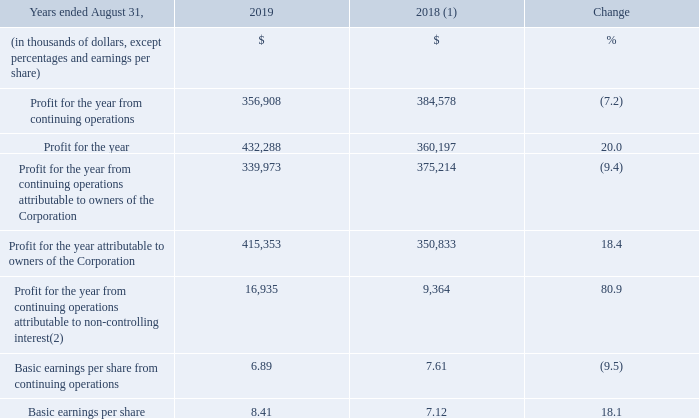3.6 PROFIT FOR THE YEAR
(1) Fiscal 2018 was restated to comply with IFRS 15 and to reflect a change in accounting policy as well as to reclassify results from Cogeco Peer 1 as discontinued operations. For further details, please consult the "Accounting policies" and "Discontinued operations" sections.
(2) The non-controlling interest represents a participation of 21% in Atlantic Broadband's results by Caisse de dépôt et placement du Québec ("CDPQ"), effective since the MetroCast acquisition on January 4, 2018.
Fiscal 2019 profit for the year from continuing operations and profit for the year from continuing operations attributable to owners of the Corporation decreased by 7.2% and 9.4%, respectively, as a result of: • last year's $94 million income tax reduction following the United States tax reform; and • the increase in depreciation and amortization mostly related to the impact of the MetroCast acquisition; partly offset by • higher adjusted EBITDA mainly as a result of the impact of the MetroCast acquisition; • the decrease in financial expense; and • the decrease in integration, restructuring and acquisition costs.
Fiscal 2019 profit for the year and profit for the year attributable to owners of the Corporation increased by 20.0% and 18.4%, respectively, mainly due to a profit for the year from discontinued operations of $75.4 million resulting from the sale of Cogeco Peer 1 in the third quarter of fiscal 2019 compared to a loss for the year from discontinued operations of $24.4 million for the prior year in addition to the elements mentioned above.
What percentage of non-controlling interest represents a participation in Atlantic Broadband? 21%. What was the increase / (decrease) in the profit for the year from continuing operations? 7.2%. By what percentage did the profit for the year attributable to owners of the Corporation increased by? 18.4%. What was the increase / (decrease) in the Profit for the year from continuing operations from 2018 to 2019?
Answer scale should be: thousand. 356,908 - 384,578
Answer: -27670. What was the average Profit for the year between 2018 and 2019?
Answer scale should be: thousand. (432,288 + 360,197) / 2
Answer: 396242.5. What was the increase / (decrease) in the Basic earnings per share from continuing operations from 2018 to 2019? 6.89 - 7.61
Answer: -0.72. 